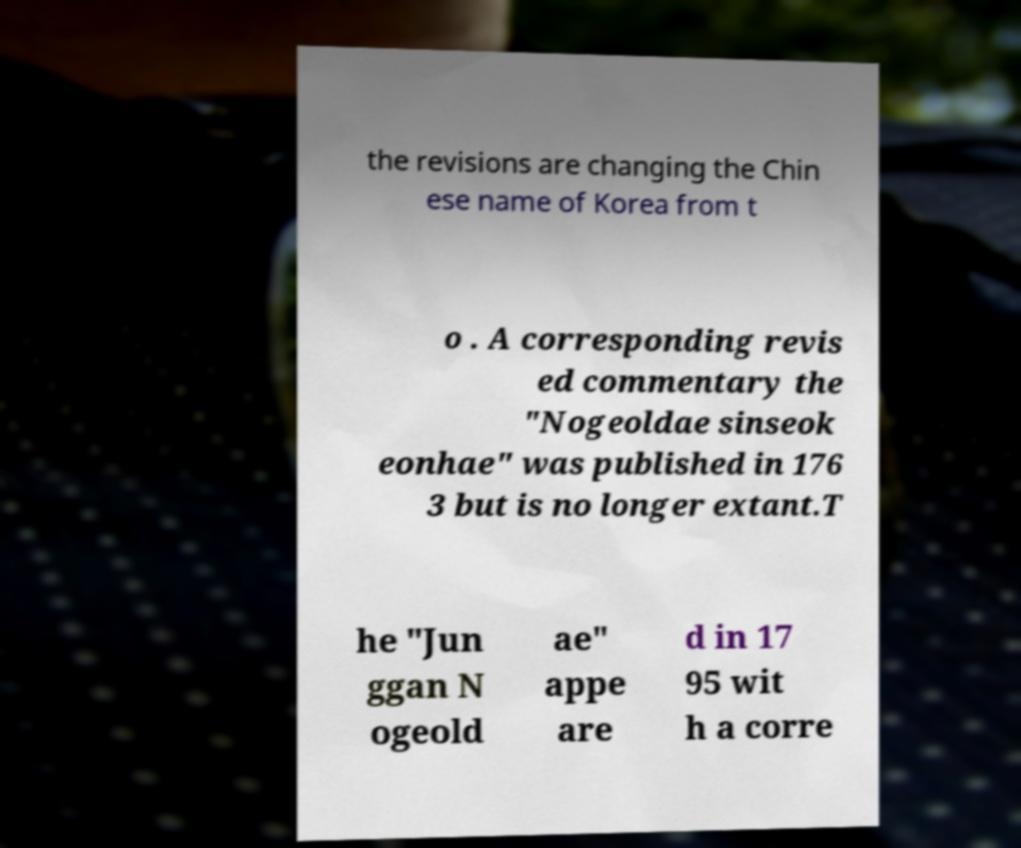I need the written content from this picture converted into text. Can you do that? the revisions are changing the Chin ese name of Korea from t o . A corresponding revis ed commentary the "Nogeoldae sinseok eonhae" was published in 176 3 but is no longer extant.T he "Jun ggan N ogeold ae" appe are d in 17 95 wit h a corre 